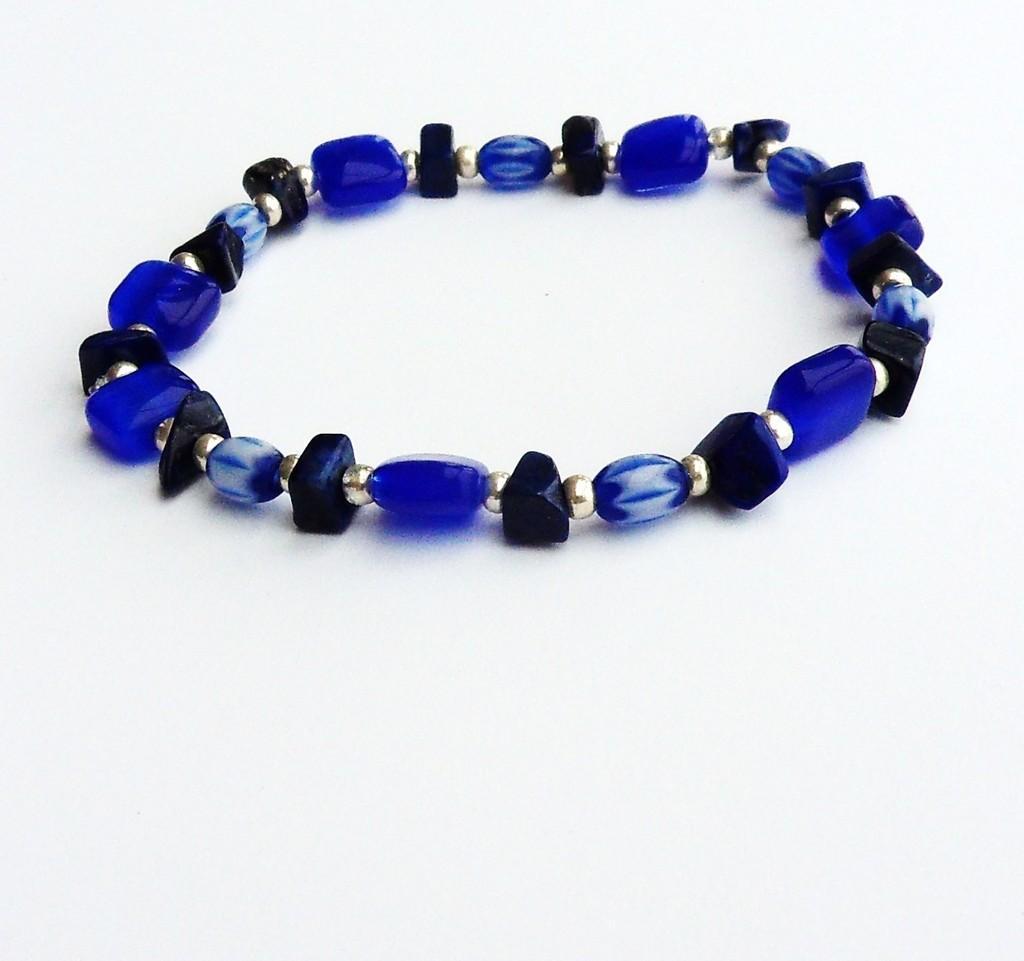In one or two sentences, can you explain what this image depicts? This picture contains a bracelet, which is in blue color. It is made up of silver color beads. In the background, it is white in color. 